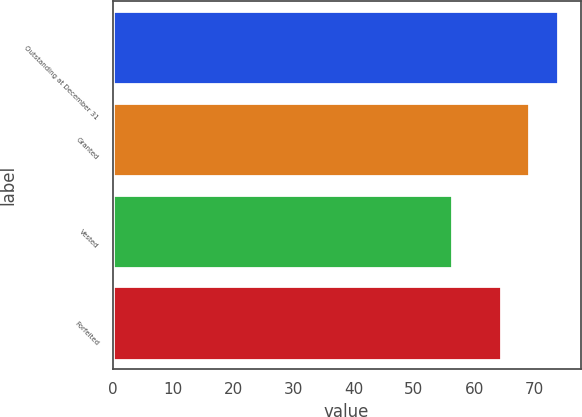Convert chart to OTSL. <chart><loc_0><loc_0><loc_500><loc_500><bar_chart><fcel>Outstanding at December 31<fcel>Granted<fcel>Vested<fcel>Forfeited<nl><fcel>73.95<fcel>69.06<fcel>56.37<fcel>64.5<nl></chart> 